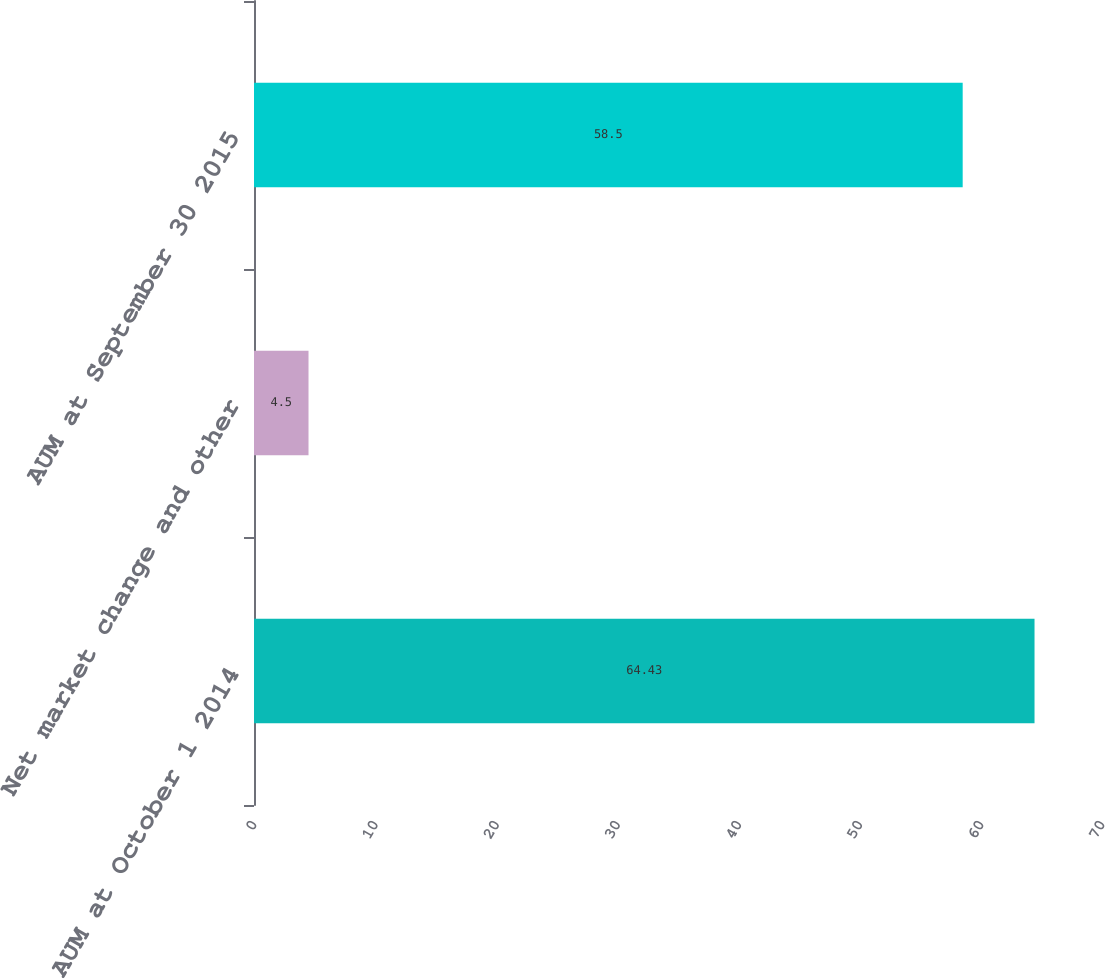<chart> <loc_0><loc_0><loc_500><loc_500><bar_chart><fcel>AUM at October 1 2014<fcel>Net market change and other<fcel>AUM at September 30 2015<nl><fcel>64.43<fcel>4.5<fcel>58.5<nl></chart> 